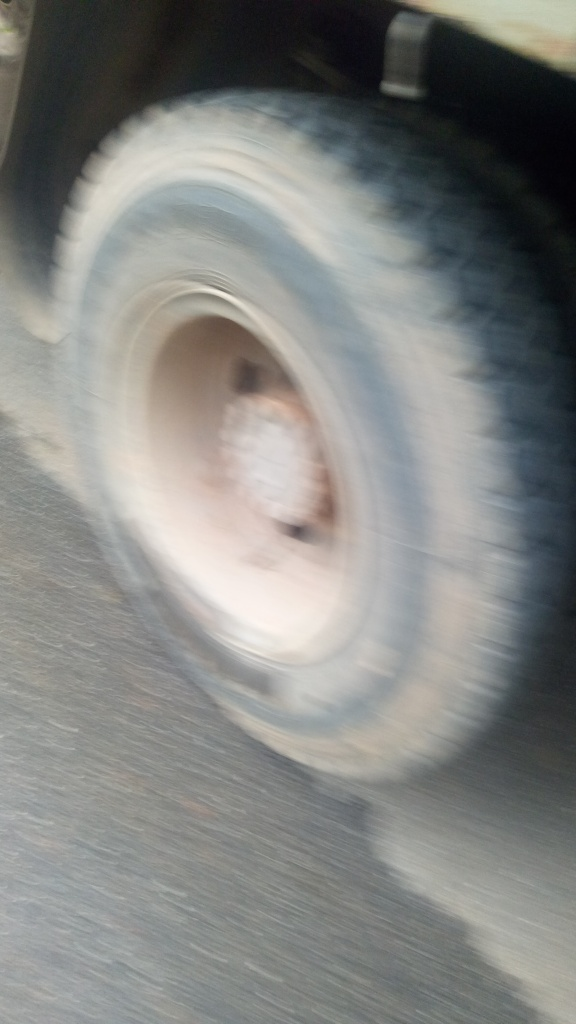Is there anything in this image that indicates where or when it might have been taken? Due to the excessive blurring, it is challenging to identify any background details that might provide context for location or time. However, the presence of a tire suggests an urban or suburban setting where vehicles are commonly used. Without distinct environmental clues or visible landmarks, it's impossible to pinpoint the exact location or timing of the photograph. The photo's lighting does not offer definitive clues regarding the time of day. 